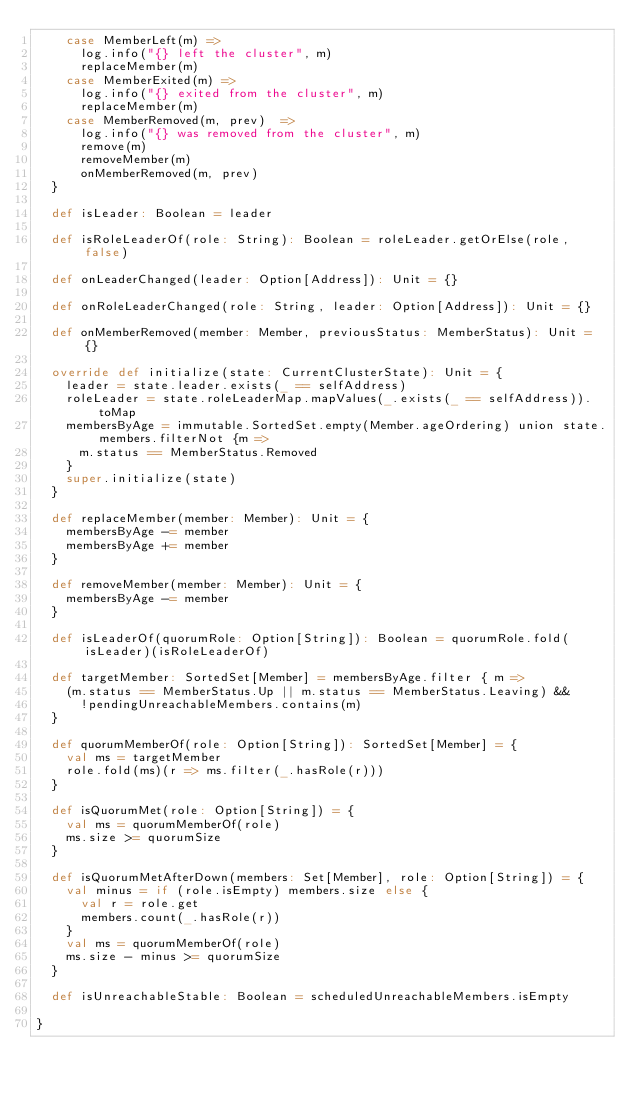<code> <loc_0><loc_0><loc_500><loc_500><_Scala_>    case MemberLeft(m) =>
      log.info("{} left the cluster", m)
      replaceMember(m)
    case MemberExited(m) =>
      log.info("{} exited from the cluster", m)
      replaceMember(m)
    case MemberRemoved(m, prev)  =>
      log.info("{} was removed from the cluster", m)
      remove(m)
      removeMember(m)
      onMemberRemoved(m, prev)
  }

  def isLeader: Boolean = leader

  def isRoleLeaderOf(role: String): Boolean = roleLeader.getOrElse(role, false)

  def onLeaderChanged(leader: Option[Address]): Unit = {}

  def onRoleLeaderChanged(role: String, leader: Option[Address]): Unit = {}

  def onMemberRemoved(member: Member, previousStatus: MemberStatus): Unit = {}

  override def initialize(state: CurrentClusterState): Unit = {
    leader = state.leader.exists(_ == selfAddress)
    roleLeader = state.roleLeaderMap.mapValues(_.exists(_ == selfAddress)).toMap
    membersByAge = immutable.SortedSet.empty(Member.ageOrdering) union state.members.filterNot {m =>
      m.status == MemberStatus.Removed
    }
    super.initialize(state)
  }

  def replaceMember(member: Member): Unit = {
    membersByAge -= member
    membersByAge += member
  }

  def removeMember(member: Member): Unit = {
    membersByAge -= member
  }

  def isLeaderOf(quorumRole: Option[String]): Boolean = quorumRole.fold(isLeader)(isRoleLeaderOf)

  def targetMember: SortedSet[Member] = membersByAge.filter { m =>
    (m.status == MemberStatus.Up || m.status == MemberStatus.Leaving) &&
      !pendingUnreachableMembers.contains(m)
  }

  def quorumMemberOf(role: Option[String]): SortedSet[Member] = {
    val ms = targetMember
    role.fold(ms)(r => ms.filter(_.hasRole(r)))
  }

  def isQuorumMet(role: Option[String]) = {
    val ms = quorumMemberOf(role)
    ms.size >= quorumSize
  }

  def isQuorumMetAfterDown(members: Set[Member], role: Option[String]) = {
    val minus = if (role.isEmpty) members.size else {
      val r = role.get
      members.count(_.hasRole(r))
    }
    val ms = quorumMemberOf(role)
    ms.size - minus >= quorumSize
  }

  def isUnreachableStable: Boolean = scheduledUnreachableMembers.isEmpty

}
</code> 